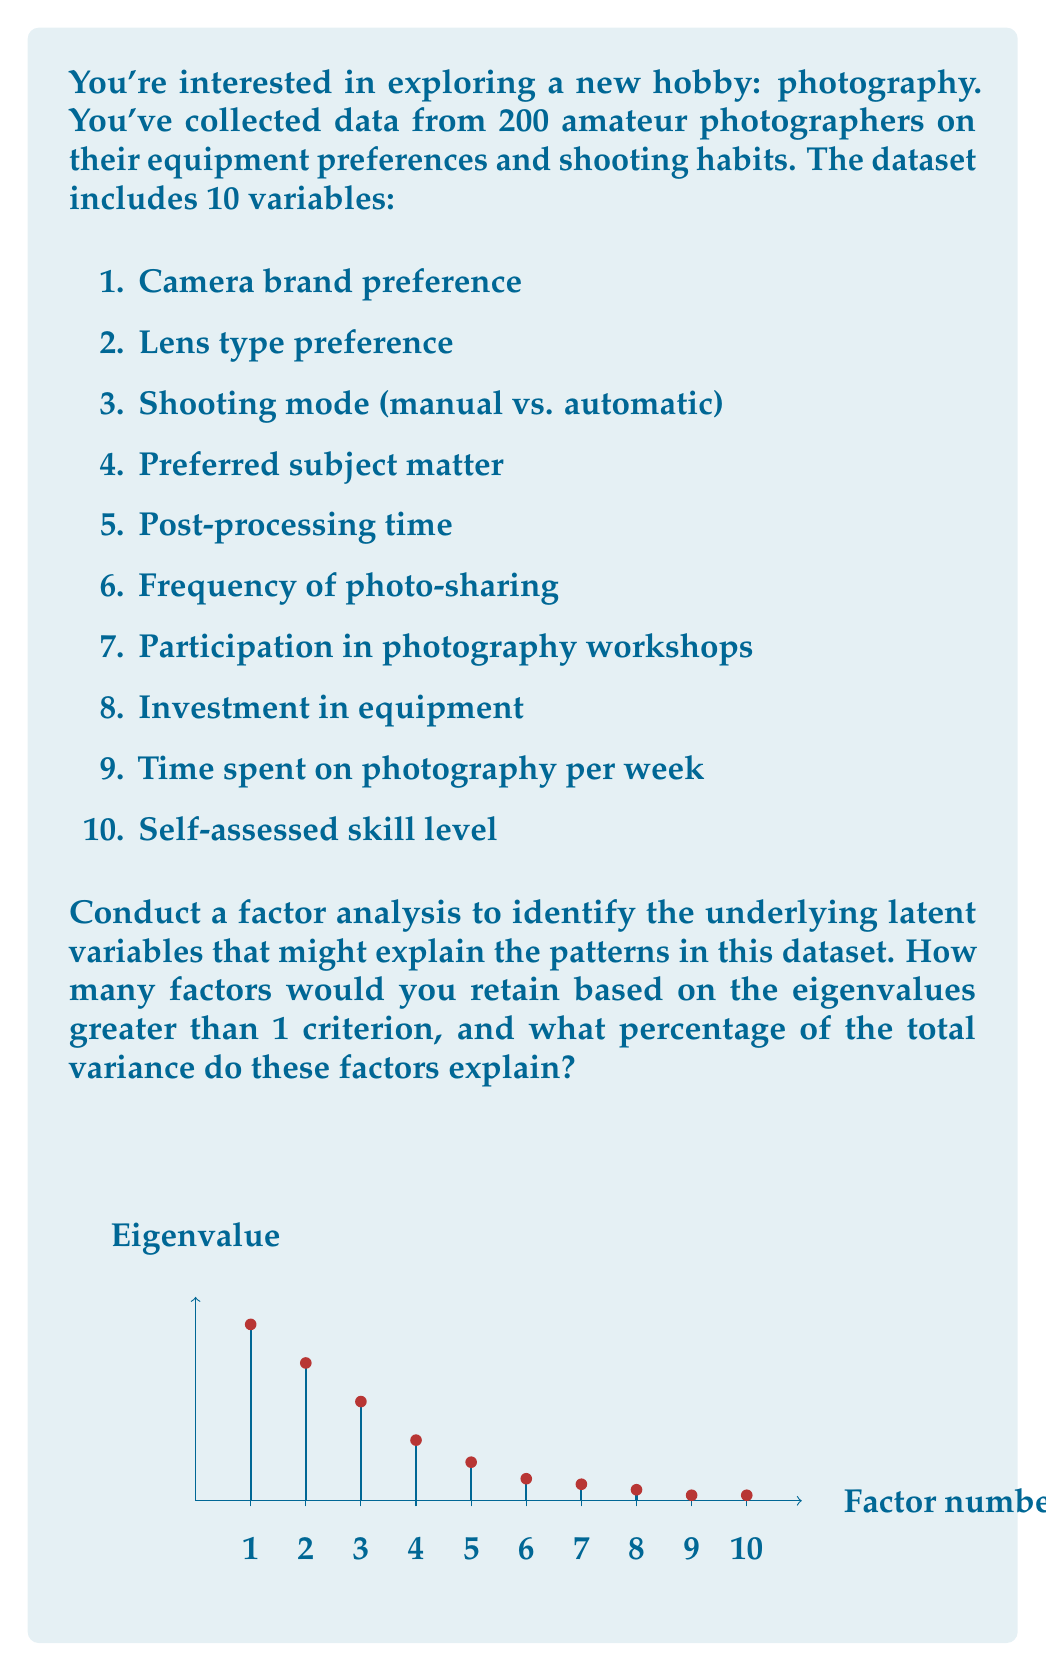Provide a solution to this math problem. To answer this question, we'll follow these steps:

1. Interpret the scree plot:
   The scree plot shows the eigenvalues for each factor. We're using the Kaiser criterion (eigenvalues > 1) to determine which factors to retain.

2. Count factors with eigenvalues > 1:
   From the plot, we can see that 4 factors have eigenvalues greater than 1:
   Factor 1: 3.2
   Factor 2: 2.5
   Factor 3: 1.8
   Factor 4: 1.1

3. Calculate the total variance explained:
   To find the percentage of total variance explained, we need to:
   a) Sum the eigenvalues of retained factors
   b) Divide by the total number of variables (which equals the sum of all eigenvalues)
   c) Multiply by 100

   $\text{Total variance explained} = \frac{\sum \text{Retained eigenvalues}}{\sum \text{All eigenvalues}} \times 100\%$

   $\sum \text{Retained eigenvalues} = 3.2 + 2.5 + 1.8 + 1.1 = 8.6$
   $\sum \text{All eigenvalues} = 3.2 + 2.5 + 1.8 + 1.1 + 0.7 + 0.4 + 0.3 + 0.2 + 0.1 + 0.1 = 10.4$

   $\text{Total variance explained} = \frac{8.6}{10.4} \times 100\% \approx 82.69\%$

Therefore, we would retain 4 factors, which explain approximately 82.69% of the total variance in the dataset.
Answer: 4 factors, 82.69% variance explained 